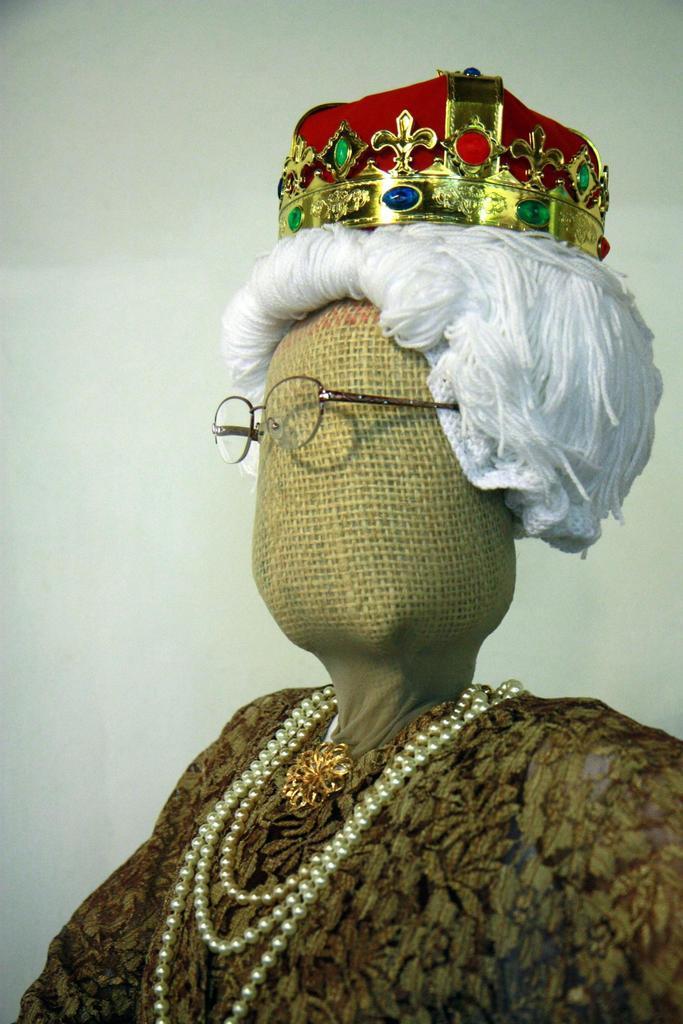Describe this image in one or two sentences. In this image we can see a doll with a crown and spectacles. 